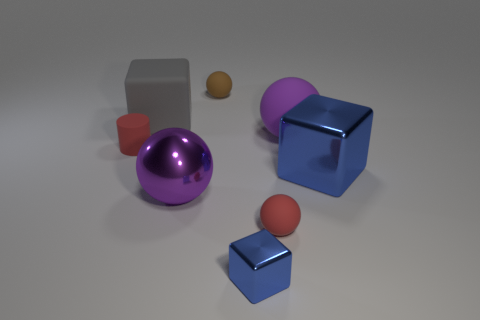Add 1 purple metal spheres. How many objects exist? 9 Subtract all cylinders. How many objects are left? 7 Add 2 small brown rubber objects. How many small brown rubber objects exist? 3 Subtract 1 red balls. How many objects are left? 7 Subtract all big blue cubes. Subtract all red balls. How many objects are left? 6 Add 2 tiny blue metal blocks. How many tiny blue metal blocks are left? 3 